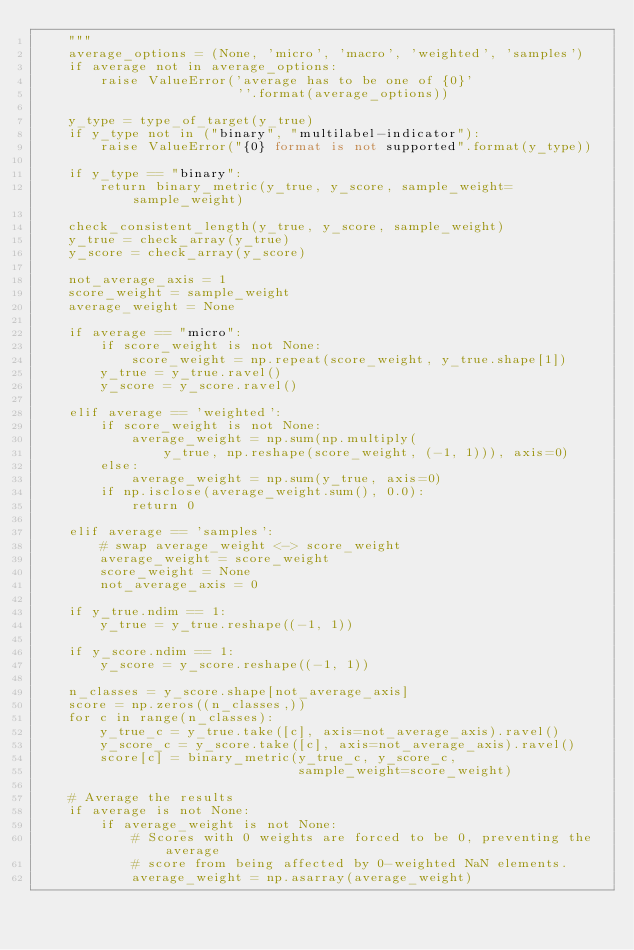<code> <loc_0><loc_0><loc_500><loc_500><_Python_>    """
    average_options = (None, 'micro', 'macro', 'weighted', 'samples')
    if average not in average_options:
        raise ValueError('average has to be one of {0}'
                         ''.format(average_options))

    y_type = type_of_target(y_true)
    if y_type not in ("binary", "multilabel-indicator"):
        raise ValueError("{0} format is not supported".format(y_type))

    if y_type == "binary":
        return binary_metric(y_true, y_score, sample_weight=sample_weight)

    check_consistent_length(y_true, y_score, sample_weight)
    y_true = check_array(y_true)
    y_score = check_array(y_score)

    not_average_axis = 1
    score_weight = sample_weight
    average_weight = None

    if average == "micro":
        if score_weight is not None:
            score_weight = np.repeat(score_weight, y_true.shape[1])
        y_true = y_true.ravel()
        y_score = y_score.ravel()

    elif average == 'weighted':
        if score_weight is not None:
            average_weight = np.sum(np.multiply(
                y_true, np.reshape(score_weight, (-1, 1))), axis=0)
        else:
            average_weight = np.sum(y_true, axis=0)
        if np.isclose(average_weight.sum(), 0.0):
            return 0

    elif average == 'samples':
        # swap average_weight <-> score_weight
        average_weight = score_weight
        score_weight = None
        not_average_axis = 0

    if y_true.ndim == 1:
        y_true = y_true.reshape((-1, 1))

    if y_score.ndim == 1:
        y_score = y_score.reshape((-1, 1))

    n_classes = y_score.shape[not_average_axis]
    score = np.zeros((n_classes,))
    for c in range(n_classes):
        y_true_c = y_true.take([c], axis=not_average_axis).ravel()
        y_score_c = y_score.take([c], axis=not_average_axis).ravel()
        score[c] = binary_metric(y_true_c, y_score_c,
                                 sample_weight=score_weight)

    # Average the results
    if average is not None:
        if average_weight is not None:
            # Scores with 0 weights are forced to be 0, preventing the average
            # score from being affected by 0-weighted NaN elements.
            average_weight = np.asarray(average_weight)</code> 